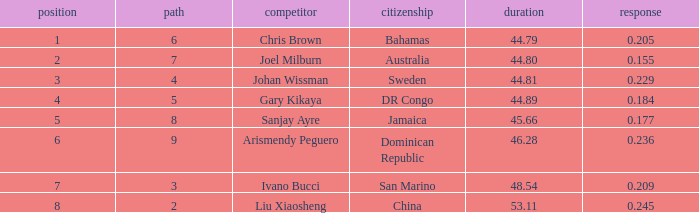How many total Time listings have a 0.209 React entry and a Rank that is greater than 7? 0.0. 